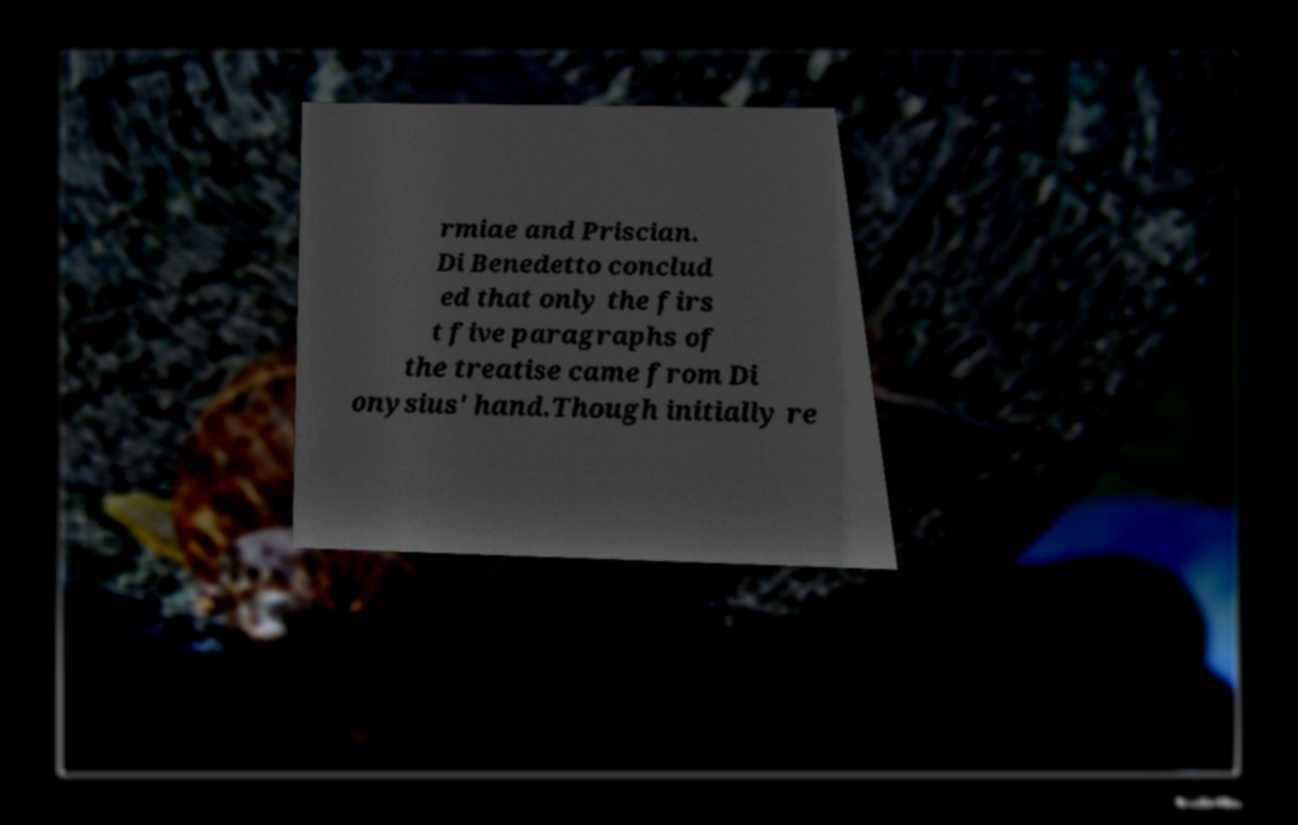Please identify and transcribe the text found in this image. rmiae and Priscian. Di Benedetto conclud ed that only the firs t five paragraphs of the treatise came from Di onysius' hand.Though initially re 